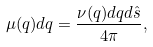<formula> <loc_0><loc_0><loc_500><loc_500>\mu ( q ) d q = \frac { \nu ( q ) d q d \hat { s } } { 4 \pi } ,</formula> 